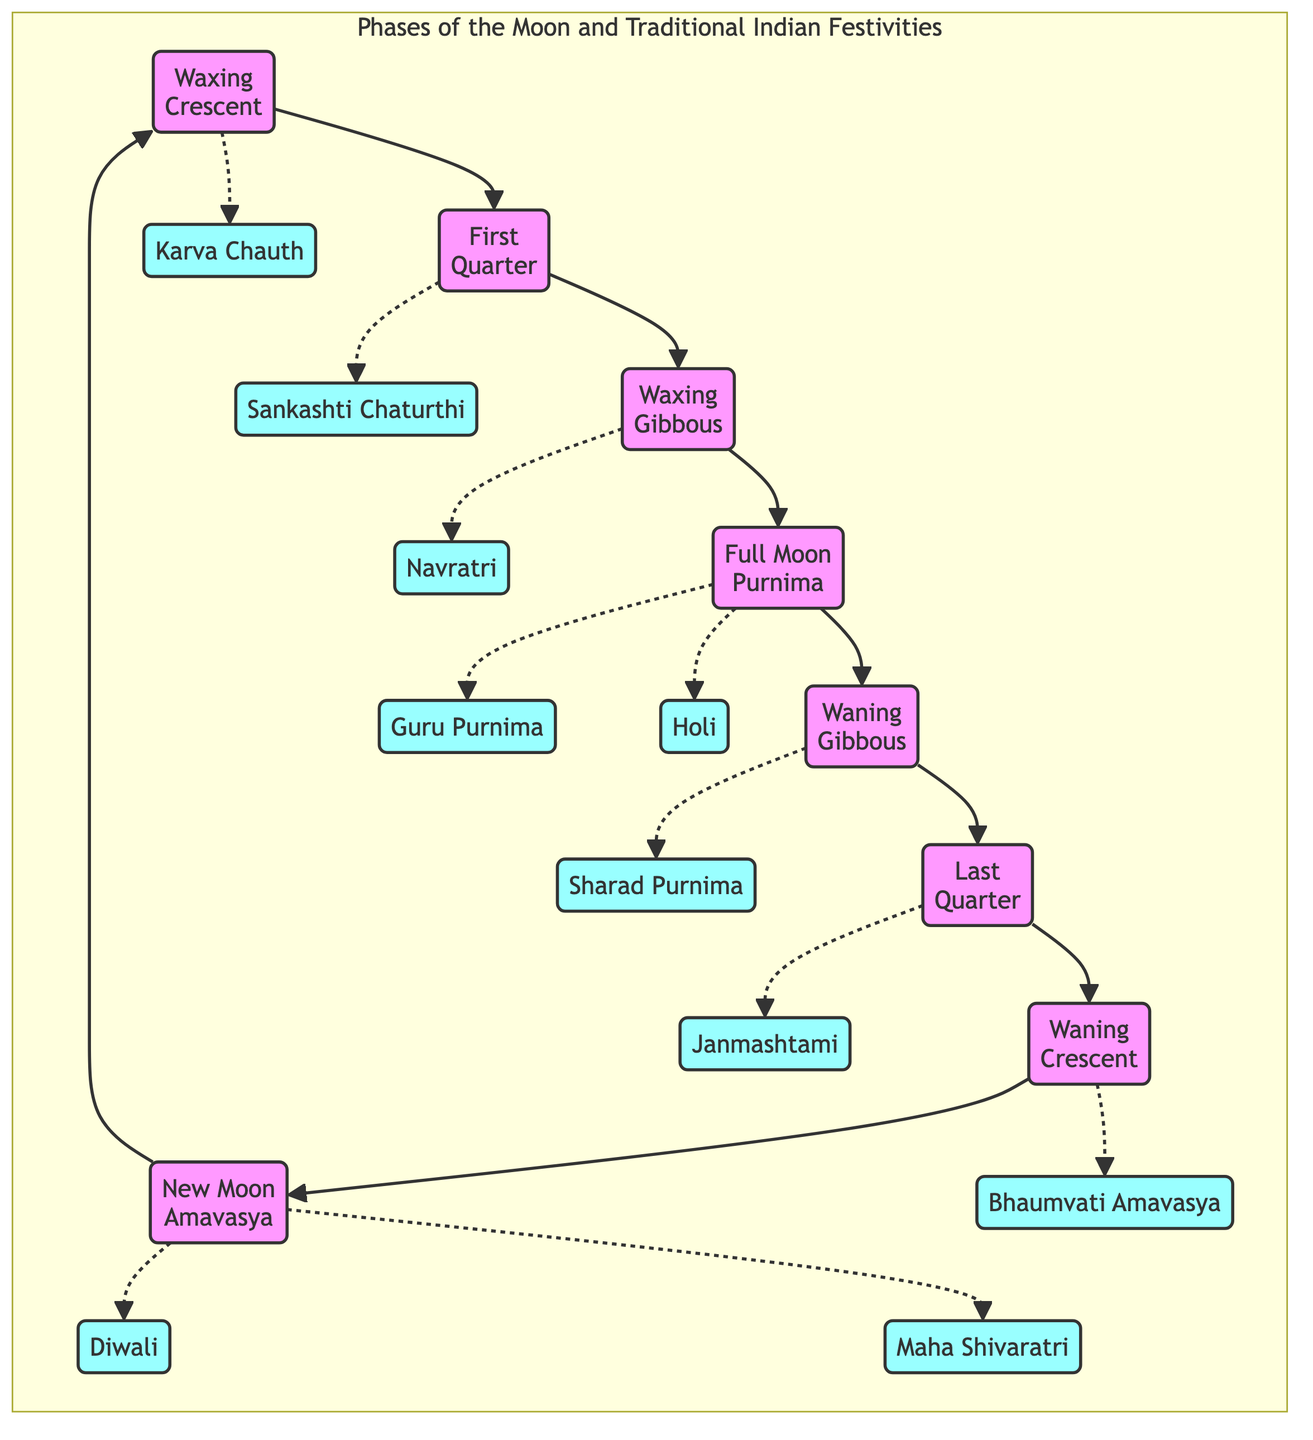What is the first phase of the moon? The diagram begins with the "New Moon" (Amavasya) as the starting point, which is the first phase in the sequence of moon phases.
Answer: New Moon (Amavasya) How many phases of the moon are represented in the diagram? The diagram illustrates a total of eight phases of the moon: New Moon, Waxing Crescent, First Quarter, Waxing Gibbous, Full Moon, Waning Gibbous, Last Quarter, and Waning Crescent.
Answer: Eight Which festival corresponds to the Full Moon phase? The diagram indicates that festivals like Guru Purnima and Holi are associated with the Full Moon phase, showing the connection between this lunar phase and specific celebrations.
Answer: Guru Purnima, Holi What festival is linked to the Waning Crescent moon phase? According to the diagram, "Bhaumvati Amavasya" is the festival connected to the Waning Crescent moon phase, showing the relationship between this lunar cycle and cultural celebrations.
Answer: Bhaumvati Amavasya What phase directly follows the First Quarter? By following the arrows in the diagram, after the First Quarter phase, the next one is the Waxing Gibbous phase, indicating the progression of the moon's cycle.
Answer: Waxing Gibbous Which festival is associated with the Waxing Crescent moon? The diagram shows that the Waxing Crescent phase is associated with "Karva Chauth," highlighting how this lunar phase serves as a backdrop for this Indian festival.
Answer: Karva Chauth Name the festival that occurs during Amavasya. The diagram specifies two festivals linked to the New Moon phase (Amavasya), which are "Diwali" and "Maha Shivaratri," showing the significance of this lunar phase in festivities.
Answer: Diwali, Maha Shivaratri What phase precedes the Last Quarter? In the sequence of phases shown in the diagram, the phase that comes before the Last Quarter is the Waning Gibbous, demonstrating the order of moon phases leading up to it.
Answer: Waning Gibbous Which festivals are celebrated during the Waxing Gibbous phase? The diagram indicates that "Navratri" is the festival associated with the Waxing Gibbous phase, indicating a direct connection between the lunar cycle and this cultural celebration.
Answer: Navratri 